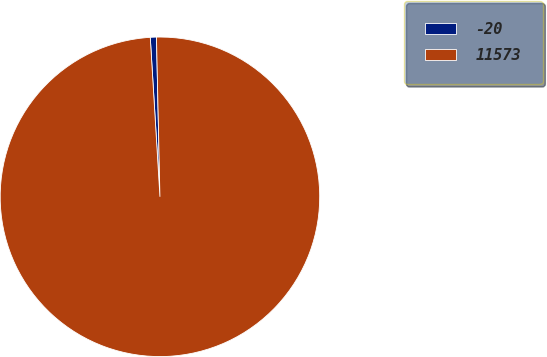Convert chart. <chart><loc_0><loc_0><loc_500><loc_500><pie_chart><fcel>-20<fcel>11573<nl><fcel>0.62%<fcel>99.38%<nl></chart> 